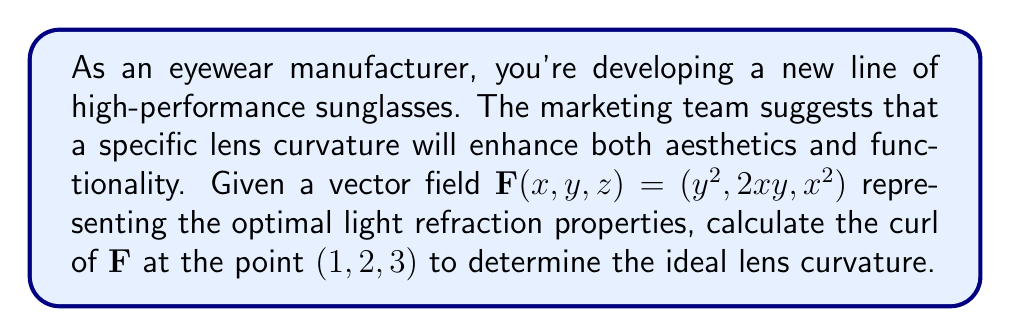Give your solution to this math problem. To calculate the curl of the vector field $\mathbf{F}(x,y,z) = (y^2, 2xy, x^2)$ at the point $(1,2,3)$, we'll follow these steps:

1) The curl of a vector field $\mathbf{F}(x,y,z) = (P,Q,R)$ is defined as:

   $$\text{curl }\mathbf{F} = \nabla \times \mathbf{F} = \left(\frac{\partial R}{\partial y} - \frac{\partial Q}{\partial z}, \frac{\partial P}{\partial z} - \frac{\partial R}{\partial x}, \frac{\partial Q}{\partial x} - \frac{\partial P}{\partial y}\right)$$

2) For our vector field:
   $P = y^2$
   $Q = 2xy$
   $R = x^2$

3) Calculate the partial derivatives:
   $\frac{\partial R}{\partial y} = 0$
   $\frac{\partial Q}{\partial z} = 0$
   $\frac{\partial P}{\partial z} = 0$
   $\frac{\partial R}{\partial x} = 2x$
   $\frac{\partial Q}{\partial x} = 2y$
   $\frac{\partial P}{\partial y} = 2y$

4) Substitute these into the curl formula:
   $$\text{curl }\mathbf{F} = (0 - 0, 0 - 2x, 2y - 2y) = (0, -2x, 0)$$

5) Evaluate at the point $(1,2,3)$:
   $$\text{curl }\mathbf{F}(1,2,3) = (0, -2(1), 0) = (0, -2, 0)$$

This result represents the optimal lens curvature at the given point, which can be used to guide the manufacturing process for the new sunglasses line.
Answer: $(0, -2, 0)$ 